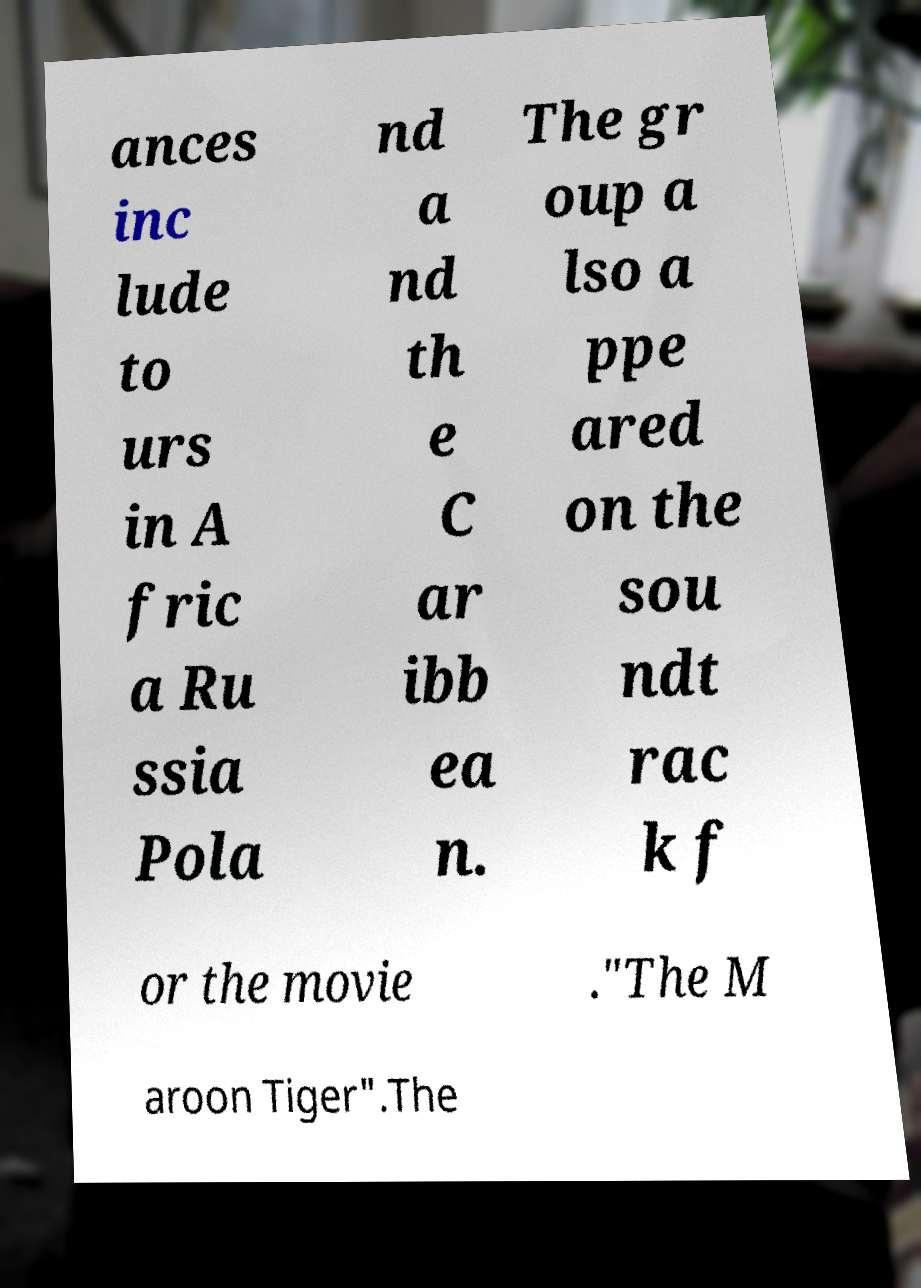There's text embedded in this image that I need extracted. Can you transcribe it verbatim? ances inc lude to urs in A fric a Ru ssia Pola nd a nd th e C ar ibb ea n. The gr oup a lso a ppe ared on the sou ndt rac k f or the movie ."The M aroon Tiger".The 